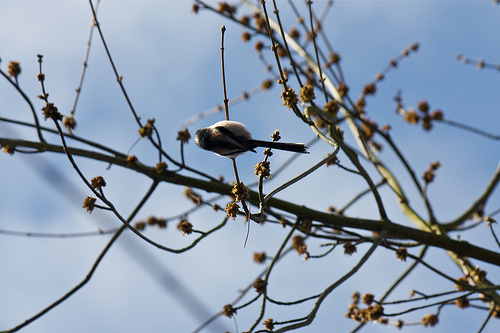<image>
Is the bird on the tree? Yes. Looking at the image, I can see the bird is positioned on top of the tree, with the tree providing support. 